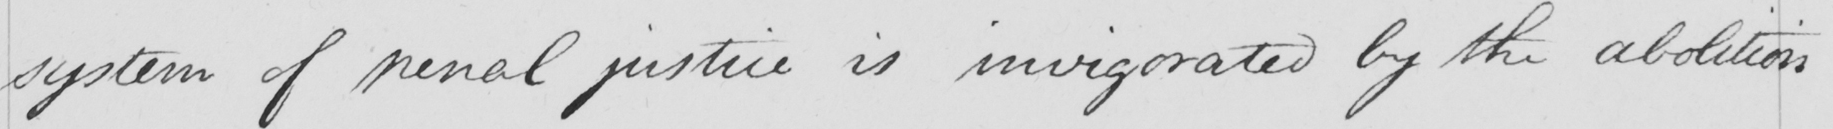Can you tell me what this handwritten text says? system of penal justice is invigorated by the abolition 